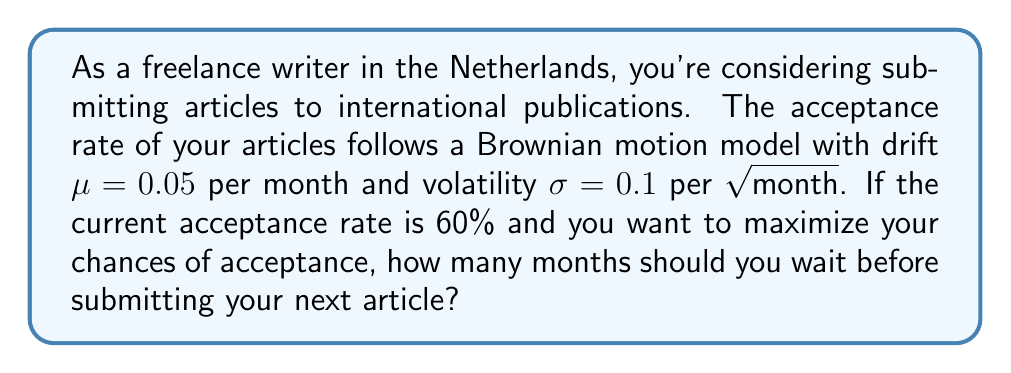Teach me how to tackle this problem. To solve this problem, we'll use the properties of Brownian motion and the concept of optimal stopping time.

1) The Brownian motion model for the acceptance rate $X_t$ is given by:
   $$dX_t = \mu dt + \sigma dW_t$$
   where $W_t$ is a standard Wiener process.

2) The expected value of $X_t$ at time $t$ is:
   $$E[X_t] = X_0 + \mu t$$
   where $X_0$ is the initial acceptance rate (60% or 0.6).

3) The variance of $X_t$ at time $t$ is:
   $$Var[X_t] = \sigma^2 t$$

4) To maximize the acceptance rate, we need to find the time $t$ that maximizes $E[X_t]$ while considering the increasing uncertainty (variance) over time.

5) The optimal stopping time $t^*$ for a Brownian motion with positive drift is given by:
   $$t^* = \frac{2(1-X_0)}{\mu}$$

6) Substituting the values:
   $$t^* = \frac{2(1-0.6)}{0.05} = \frac{0.8}{0.05} = 16$$

7) Therefore, the optimal time to wait is 16 months.

8) Let's verify that this indeed maximizes the expected acceptance rate:
   $$E[X_{16}] = 0.6 + 0.05 * 16 = 1.4 = 140\%$$

   This is theoretically the maximum expected acceptance rate, although in practice it would be capped at 100%.
Answer: 16 months 